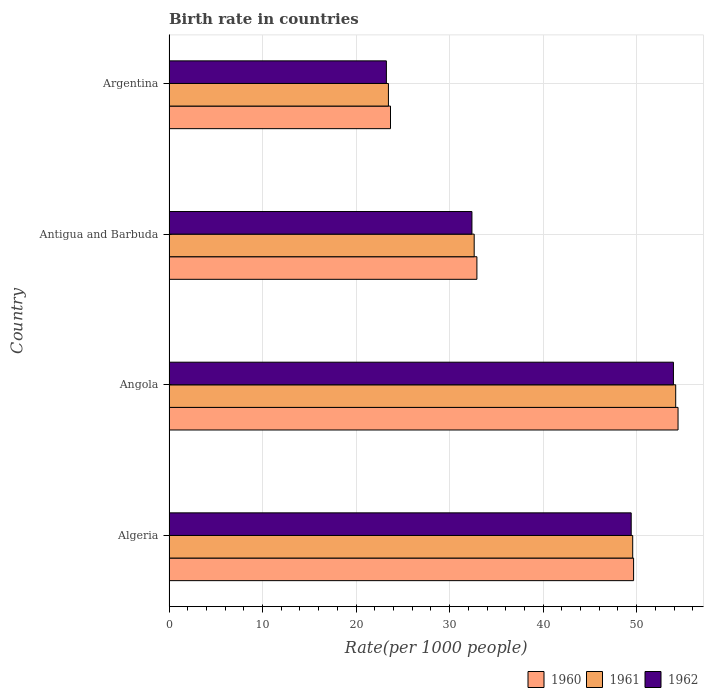Are the number of bars on each tick of the Y-axis equal?
Keep it short and to the point. Yes. How many bars are there on the 1st tick from the top?
Offer a terse response. 3. How many bars are there on the 2nd tick from the bottom?
Make the answer very short. 3. What is the label of the 4th group of bars from the top?
Offer a very short reply. Algeria. What is the birth rate in 1962 in Algeria?
Offer a very short reply. 49.42. Across all countries, what is the maximum birth rate in 1961?
Make the answer very short. 54.17. Across all countries, what is the minimum birth rate in 1960?
Your response must be concise. 23.68. In which country was the birth rate in 1962 maximum?
Give a very brief answer. Angola. What is the total birth rate in 1962 in the graph?
Ensure brevity in your answer.  158.98. What is the difference between the birth rate in 1960 in Angola and that in Argentina?
Provide a short and direct response. 30.74. What is the difference between the birth rate in 1961 in Antigua and Barbuda and the birth rate in 1962 in Algeria?
Make the answer very short. -16.79. What is the average birth rate in 1962 per country?
Your response must be concise. 39.74. What is the difference between the birth rate in 1962 and birth rate in 1960 in Antigua and Barbuda?
Your answer should be very brief. -0.53. In how many countries, is the birth rate in 1961 greater than 26 ?
Provide a succinct answer. 3. What is the ratio of the birth rate in 1960 in Angola to that in Antigua and Barbuda?
Provide a short and direct response. 1.65. Is the birth rate in 1962 in Angola less than that in Antigua and Barbuda?
Provide a short and direct response. No. What is the difference between the highest and the second highest birth rate in 1960?
Your response must be concise. 4.75. What is the difference between the highest and the lowest birth rate in 1962?
Offer a very short reply. 30.69. What does the 2nd bar from the bottom in Argentina represents?
Provide a short and direct response. 1961. Are all the bars in the graph horizontal?
Ensure brevity in your answer.  Yes. What is the difference between two consecutive major ticks on the X-axis?
Your answer should be compact. 10. Does the graph contain any zero values?
Ensure brevity in your answer.  No. Does the graph contain grids?
Keep it short and to the point. Yes. Where does the legend appear in the graph?
Make the answer very short. Bottom right. How many legend labels are there?
Offer a terse response. 3. How are the legend labels stacked?
Make the answer very short. Horizontal. What is the title of the graph?
Keep it short and to the point. Birth rate in countries. Does "1993" appear as one of the legend labels in the graph?
Ensure brevity in your answer.  No. What is the label or title of the X-axis?
Give a very brief answer. Rate(per 1000 people). What is the label or title of the Y-axis?
Offer a terse response. Country. What is the Rate(per 1000 people) in 1960 in Algeria?
Offer a terse response. 49.67. What is the Rate(per 1000 people) in 1961 in Algeria?
Ensure brevity in your answer.  49.58. What is the Rate(per 1000 people) in 1962 in Algeria?
Provide a succinct answer. 49.42. What is the Rate(per 1000 people) in 1960 in Angola?
Offer a terse response. 54.42. What is the Rate(per 1000 people) of 1961 in Angola?
Make the answer very short. 54.17. What is the Rate(per 1000 people) of 1962 in Angola?
Provide a short and direct response. 53.93. What is the Rate(per 1000 people) of 1960 in Antigua and Barbuda?
Give a very brief answer. 32.92. What is the Rate(per 1000 people) of 1961 in Antigua and Barbuda?
Your response must be concise. 32.63. What is the Rate(per 1000 people) of 1962 in Antigua and Barbuda?
Offer a terse response. 32.39. What is the Rate(per 1000 people) in 1960 in Argentina?
Provide a short and direct response. 23.68. What is the Rate(per 1000 people) in 1961 in Argentina?
Offer a very short reply. 23.46. What is the Rate(per 1000 people) in 1962 in Argentina?
Make the answer very short. 23.24. Across all countries, what is the maximum Rate(per 1000 people) of 1960?
Offer a terse response. 54.42. Across all countries, what is the maximum Rate(per 1000 people) in 1961?
Keep it short and to the point. 54.17. Across all countries, what is the maximum Rate(per 1000 people) of 1962?
Provide a short and direct response. 53.93. Across all countries, what is the minimum Rate(per 1000 people) in 1960?
Provide a succinct answer. 23.68. Across all countries, what is the minimum Rate(per 1000 people) of 1961?
Your answer should be compact. 23.46. Across all countries, what is the minimum Rate(per 1000 people) of 1962?
Your response must be concise. 23.24. What is the total Rate(per 1000 people) in 1960 in the graph?
Your answer should be very brief. 160.7. What is the total Rate(per 1000 people) of 1961 in the graph?
Your answer should be compact. 159.84. What is the total Rate(per 1000 people) of 1962 in the graph?
Make the answer very short. 158.98. What is the difference between the Rate(per 1000 people) of 1960 in Algeria and that in Angola?
Your answer should be compact. -4.75. What is the difference between the Rate(per 1000 people) in 1961 in Algeria and that in Angola?
Keep it short and to the point. -4.6. What is the difference between the Rate(per 1000 people) of 1962 in Algeria and that in Angola?
Make the answer very short. -4.51. What is the difference between the Rate(per 1000 people) of 1960 in Algeria and that in Antigua and Barbuda?
Your answer should be compact. 16.75. What is the difference between the Rate(per 1000 people) of 1961 in Algeria and that in Antigua and Barbuda?
Provide a short and direct response. 16.95. What is the difference between the Rate(per 1000 people) in 1962 in Algeria and that in Antigua and Barbuda?
Make the answer very short. 17.03. What is the difference between the Rate(per 1000 people) in 1960 in Algeria and that in Argentina?
Offer a very short reply. 25.99. What is the difference between the Rate(per 1000 people) in 1961 in Algeria and that in Argentina?
Keep it short and to the point. 26.12. What is the difference between the Rate(per 1000 people) in 1962 in Algeria and that in Argentina?
Provide a succinct answer. 26.17. What is the difference between the Rate(per 1000 people) in 1960 in Angola and that in Antigua and Barbuda?
Give a very brief answer. 21.5. What is the difference between the Rate(per 1000 people) in 1961 in Angola and that in Antigua and Barbuda?
Offer a terse response. 21.55. What is the difference between the Rate(per 1000 people) of 1962 in Angola and that in Antigua and Barbuda?
Your response must be concise. 21.54. What is the difference between the Rate(per 1000 people) of 1960 in Angola and that in Argentina?
Give a very brief answer. 30.74. What is the difference between the Rate(per 1000 people) in 1961 in Angola and that in Argentina?
Give a very brief answer. 30.71. What is the difference between the Rate(per 1000 people) of 1962 in Angola and that in Argentina?
Keep it short and to the point. 30.69. What is the difference between the Rate(per 1000 people) of 1960 in Antigua and Barbuda and that in Argentina?
Your answer should be compact. 9.24. What is the difference between the Rate(per 1000 people) in 1961 in Antigua and Barbuda and that in Argentina?
Ensure brevity in your answer.  9.17. What is the difference between the Rate(per 1000 people) of 1962 in Antigua and Barbuda and that in Argentina?
Your response must be concise. 9.15. What is the difference between the Rate(per 1000 people) in 1960 in Algeria and the Rate(per 1000 people) in 1961 in Angola?
Ensure brevity in your answer.  -4.5. What is the difference between the Rate(per 1000 people) of 1960 in Algeria and the Rate(per 1000 people) of 1962 in Angola?
Give a very brief answer. -4.26. What is the difference between the Rate(per 1000 people) in 1961 in Algeria and the Rate(per 1000 people) in 1962 in Angola?
Give a very brief answer. -4.36. What is the difference between the Rate(per 1000 people) in 1960 in Algeria and the Rate(per 1000 people) in 1961 in Antigua and Barbuda?
Your response must be concise. 17.04. What is the difference between the Rate(per 1000 people) of 1960 in Algeria and the Rate(per 1000 people) of 1962 in Antigua and Barbuda?
Provide a short and direct response. 17.28. What is the difference between the Rate(per 1000 people) of 1961 in Algeria and the Rate(per 1000 people) of 1962 in Antigua and Barbuda?
Offer a terse response. 17.19. What is the difference between the Rate(per 1000 people) in 1960 in Algeria and the Rate(per 1000 people) in 1961 in Argentina?
Ensure brevity in your answer.  26.21. What is the difference between the Rate(per 1000 people) in 1960 in Algeria and the Rate(per 1000 people) in 1962 in Argentina?
Your answer should be very brief. 26.43. What is the difference between the Rate(per 1000 people) in 1961 in Algeria and the Rate(per 1000 people) in 1962 in Argentina?
Give a very brief answer. 26.33. What is the difference between the Rate(per 1000 people) in 1960 in Angola and the Rate(per 1000 people) in 1961 in Antigua and Barbuda?
Offer a very short reply. 21.8. What is the difference between the Rate(per 1000 people) of 1960 in Angola and the Rate(per 1000 people) of 1962 in Antigua and Barbuda?
Offer a very short reply. 22.04. What is the difference between the Rate(per 1000 people) of 1961 in Angola and the Rate(per 1000 people) of 1962 in Antigua and Barbuda?
Ensure brevity in your answer.  21.79. What is the difference between the Rate(per 1000 people) in 1960 in Angola and the Rate(per 1000 people) in 1961 in Argentina?
Your response must be concise. 30.96. What is the difference between the Rate(per 1000 people) in 1960 in Angola and the Rate(per 1000 people) in 1962 in Argentina?
Your answer should be compact. 31.18. What is the difference between the Rate(per 1000 people) of 1961 in Angola and the Rate(per 1000 people) of 1962 in Argentina?
Provide a succinct answer. 30.93. What is the difference between the Rate(per 1000 people) of 1960 in Antigua and Barbuda and the Rate(per 1000 people) of 1961 in Argentina?
Offer a very short reply. 9.46. What is the difference between the Rate(per 1000 people) in 1960 in Antigua and Barbuda and the Rate(per 1000 people) in 1962 in Argentina?
Your answer should be very brief. 9.68. What is the difference between the Rate(per 1000 people) in 1961 in Antigua and Barbuda and the Rate(per 1000 people) in 1962 in Argentina?
Give a very brief answer. 9.39. What is the average Rate(per 1000 people) of 1960 per country?
Ensure brevity in your answer.  40.17. What is the average Rate(per 1000 people) in 1961 per country?
Make the answer very short. 39.96. What is the average Rate(per 1000 people) in 1962 per country?
Make the answer very short. 39.74. What is the difference between the Rate(per 1000 people) of 1960 and Rate(per 1000 people) of 1961 in Algeria?
Offer a very short reply. 0.1. What is the difference between the Rate(per 1000 people) in 1960 and Rate(per 1000 people) in 1962 in Algeria?
Provide a succinct answer. 0.26. What is the difference between the Rate(per 1000 people) in 1961 and Rate(per 1000 people) in 1962 in Algeria?
Your response must be concise. 0.16. What is the difference between the Rate(per 1000 people) in 1960 and Rate(per 1000 people) in 1961 in Angola?
Offer a terse response. 0.25. What is the difference between the Rate(per 1000 people) in 1960 and Rate(per 1000 people) in 1962 in Angola?
Your response must be concise. 0.49. What is the difference between the Rate(per 1000 people) in 1961 and Rate(per 1000 people) in 1962 in Angola?
Provide a short and direct response. 0.24. What is the difference between the Rate(per 1000 people) in 1960 and Rate(per 1000 people) in 1961 in Antigua and Barbuda?
Your answer should be very brief. 0.29. What is the difference between the Rate(per 1000 people) of 1960 and Rate(per 1000 people) of 1962 in Antigua and Barbuda?
Provide a short and direct response. 0.53. What is the difference between the Rate(per 1000 people) in 1961 and Rate(per 1000 people) in 1962 in Antigua and Barbuda?
Make the answer very short. 0.24. What is the difference between the Rate(per 1000 people) of 1960 and Rate(per 1000 people) of 1961 in Argentina?
Offer a terse response. 0.22. What is the difference between the Rate(per 1000 people) in 1960 and Rate(per 1000 people) in 1962 in Argentina?
Make the answer very short. 0.44. What is the difference between the Rate(per 1000 people) in 1961 and Rate(per 1000 people) in 1962 in Argentina?
Your response must be concise. 0.22. What is the ratio of the Rate(per 1000 people) in 1960 in Algeria to that in Angola?
Provide a short and direct response. 0.91. What is the ratio of the Rate(per 1000 people) of 1961 in Algeria to that in Angola?
Your response must be concise. 0.92. What is the ratio of the Rate(per 1000 people) of 1962 in Algeria to that in Angola?
Your answer should be very brief. 0.92. What is the ratio of the Rate(per 1000 people) of 1960 in Algeria to that in Antigua and Barbuda?
Offer a terse response. 1.51. What is the ratio of the Rate(per 1000 people) of 1961 in Algeria to that in Antigua and Barbuda?
Give a very brief answer. 1.52. What is the ratio of the Rate(per 1000 people) of 1962 in Algeria to that in Antigua and Barbuda?
Provide a succinct answer. 1.53. What is the ratio of the Rate(per 1000 people) of 1960 in Algeria to that in Argentina?
Keep it short and to the point. 2.1. What is the ratio of the Rate(per 1000 people) of 1961 in Algeria to that in Argentina?
Your answer should be compact. 2.11. What is the ratio of the Rate(per 1000 people) in 1962 in Algeria to that in Argentina?
Your answer should be compact. 2.13. What is the ratio of the Rate(per 1000 people) in 1960 in Angola to that in Antigua and Barbuda?
Keep it short and to the point. 1.65. What is the ratio of the Rate(per 1000 people) in 1961 in Angola to that in Antigua and Barbuda?
Keep it short and to the point. 1.66. What is the ratio of the Rate(per 1000 people) in 1962 in Angola to that in Antigua and Barbuda?
Make the answer very short. 1.67. What is the ratio of the Rate(per 1000 people) in 1960 in Angola to that in Argentina?
Ensure brevity in your answer.  2.3. What is the ratio of the Rate(per 1000 people) in 1961 in Angola to that in Argentina?
Give a very brief answer. 2.31. What is the ratio of the Rate(per 1000 people) of 1962 in Angola to that in Argentina?
Offer a very short reply. 2.32. What is the ratio of the Rate(per 1000 people) in 1960 in Antigua and Barbuda to that in Argentina?
Offer a terse response. 1.39. What is the ratio of the Rate(per 1000 people) of 1961 in Antigua and Barbuda to that in Argentina?
Make the answer very short. 1.39. What is the ratio of the Rate(per 1000 people) of 1962 in Antigua and Barbuda to that in Argentina?
Your response must be concise. 1.39. What is the difference between the highest and the second highest Rate(per 1000 people) of 1960?
Ensure brevity in your answer.  4.75. What is the difference between the highest and the second highest Rate(per 1000 people) of 1961?
Offer a terse response. 4.6. What is the difference between the highest and the second highest Rate(per 1000 people) of 1962?
Give a very brief answer. 4.51. What is the difference between the highest and the lowest Rate(per 1000 people) of 1960?
Offer a very short reply. 30.74. What is the difference between the highest and the lowest Rate(per 1000 people) of 1961?
Your answer should be compact. 30.71. What is the difference between the highest and the lowest Rate(per 1000 people) in 1962?
Keep it short and to the point. 30.69. 